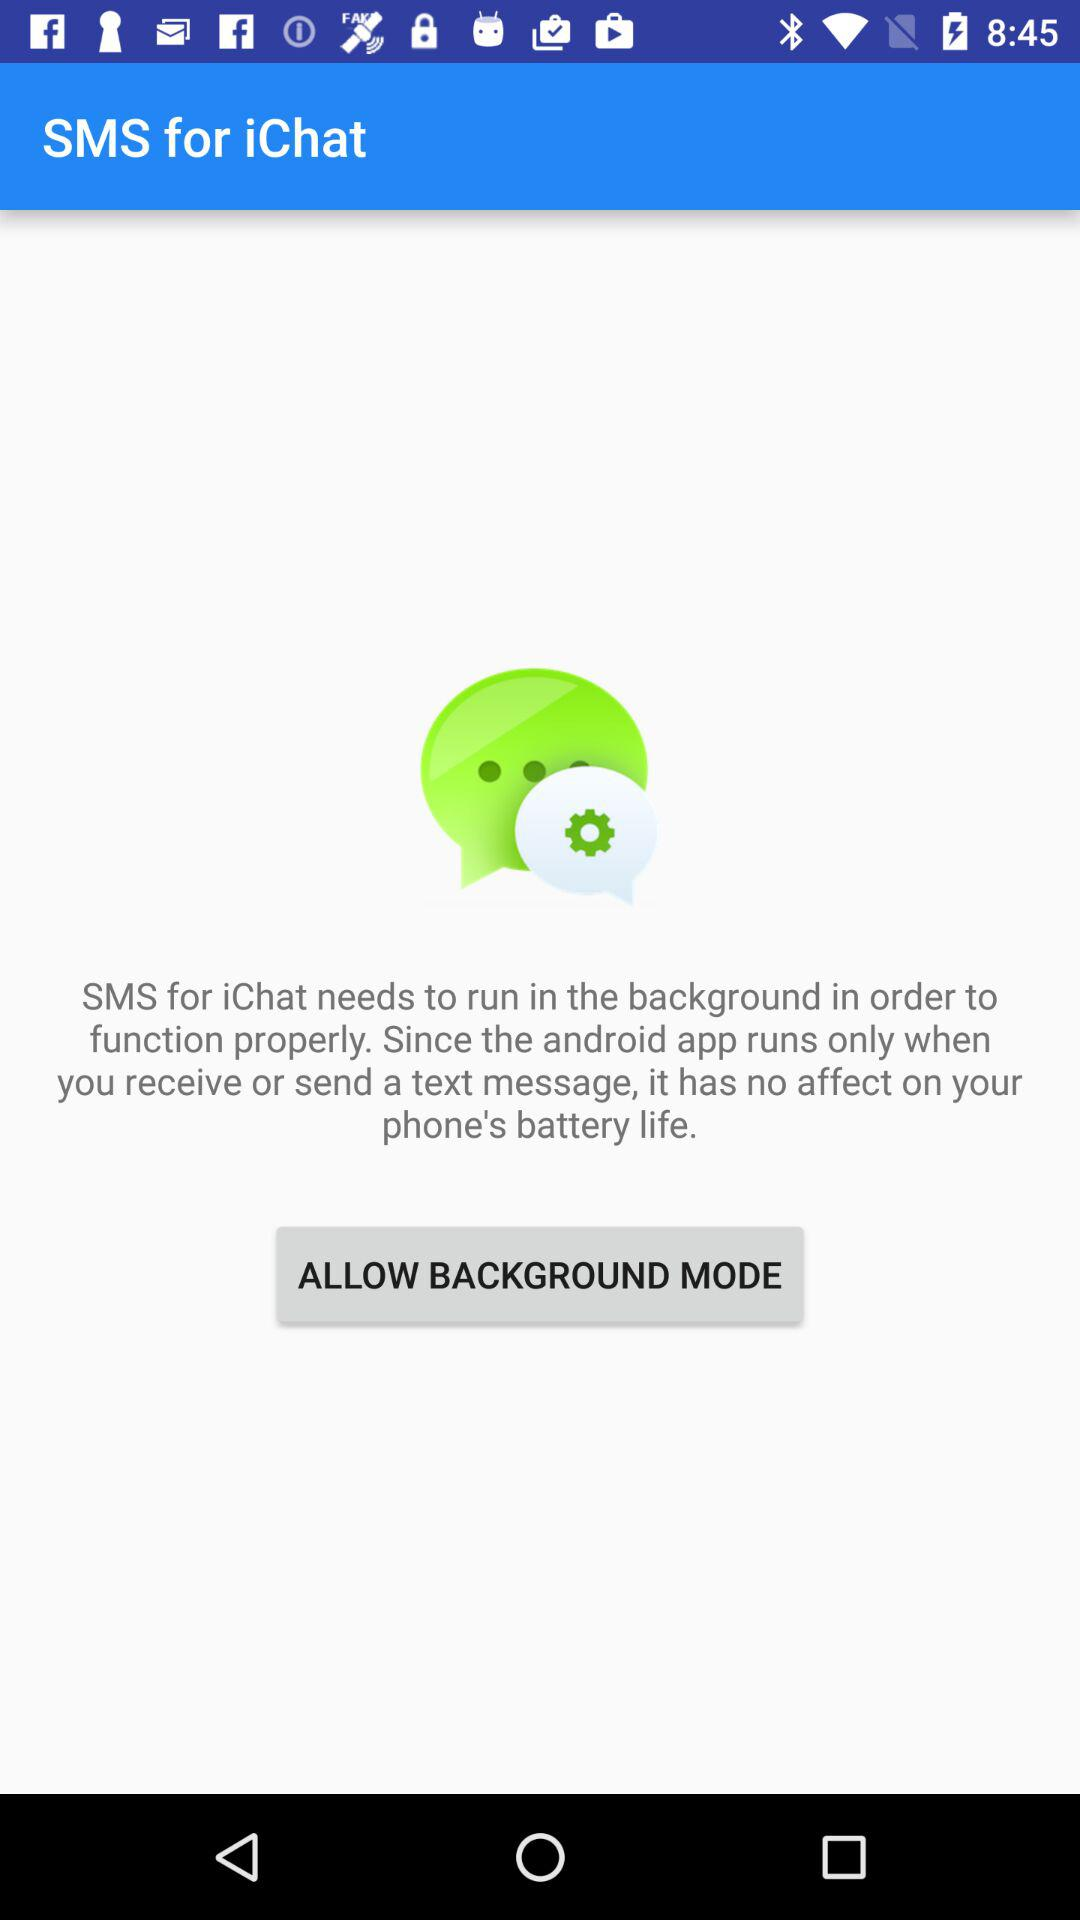What is the name of the application? The name of the application is "SMS for iChat". 